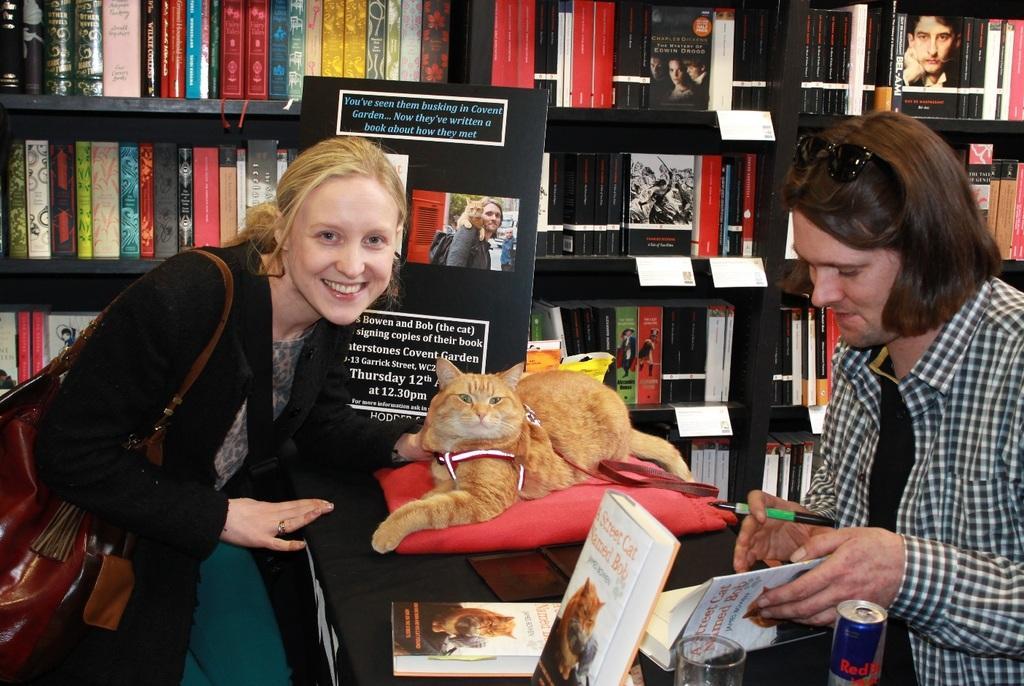In one or two sentences, can you explain what this image depicts? This woman wore black jacket, bag and smiling. In-front of this woman there is a table, on this table there is a card, cat, book, glass and tin. This man is holding a book and pen. This rack is filled with books. 